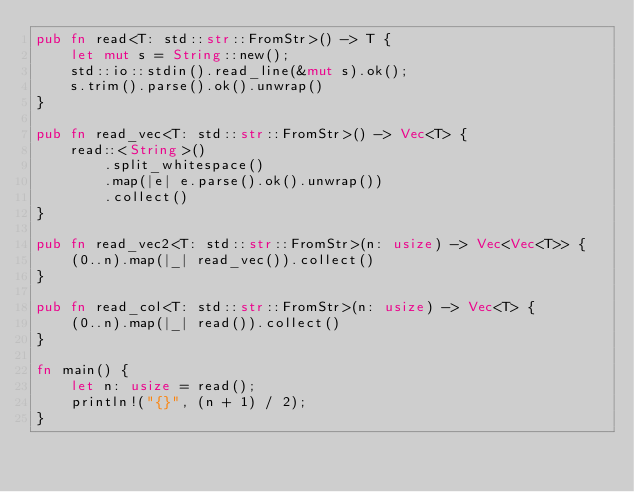Convert code to text. <code><loc_0><loc_0><loc_500><loc_500><_Rust_>pub fn read<T: std::str::FromStr>() -> T {
    let mut s = String::new();
    std::io::stdin().read_line(&mut s).ok();
    s.trim().parse().ok().unwrap()
}

pub fn read_vec<T: std::str::FromStr>() -> Vec<T> {
    read::<String>()
        .split_whitespace()
        .map(|e| e.parse().ok().unwrap())
        .collect()
}

pub fn read_vec2<T: std::str::FromStr>(n: usize) -> Vec<Vec<T>> {
    (0..n).map(|_| read_vec()).collect()
}

pub fn read_col<T: std::str::FromStr>(n: usize) -> Vec<T> {
    (0..n).map(|_| read()).collect()
}

fn main() {
    let n: usize = read();
    println!("{}", (n + 1) / 2);
}
</code> 